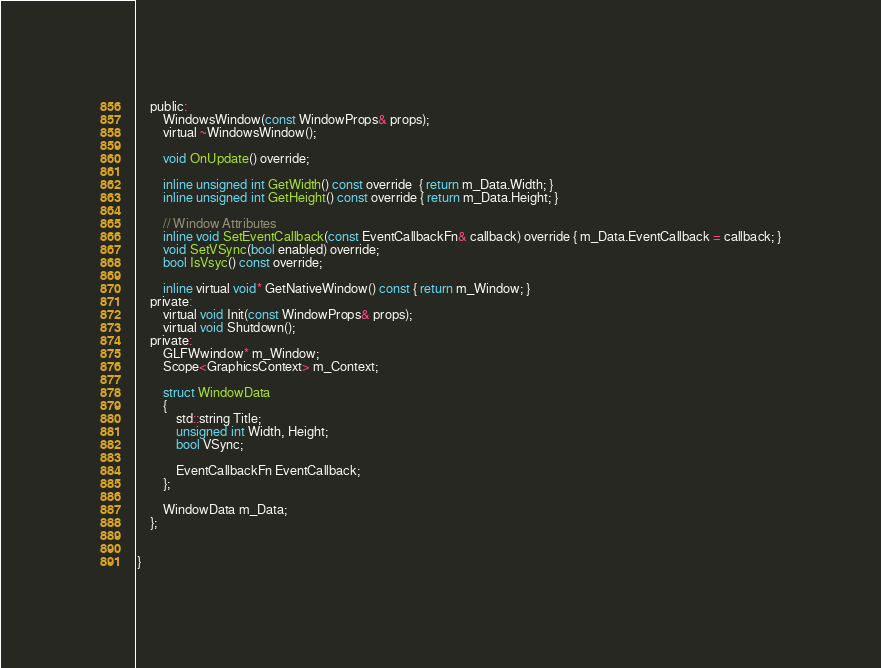<code> <loc_0><loc_0><loc_500><loc_500><_C_>	public:
		WindowsWindow(const WindowProps& props);
		virtual ~WindowsWindow();

		void OnUpdate() override;

		inline unsigned int GetWidth() const override  { return m_Data.Width; }
		inline unsigned int GetHeight() const override { return m_Data.Height; }

		// Window Attributes
		inline void SetEventCallback(const EventCallbackFn& callback) override { m_Data.EventCallback = callback; }
		void SetVSync(bool enabled) override;
		bool IsVsyc() const override;

		inline virtual void* GetNativeWindow() const { return m_Window; }
	private:
		virtual void Init(const WindowProps& props);
		virtual void Shutdown();
	private:
		GLFWwindow* m_Window;
		Scope<GraphicsContext> m_Context;

		struct WindowData
		{
			std::string Title;
			unsigned int Width, Height;
			bool VSync;

			EventCallbackFn EventCallback;
		};

		WindowData m_Data;
	};


}</code> 